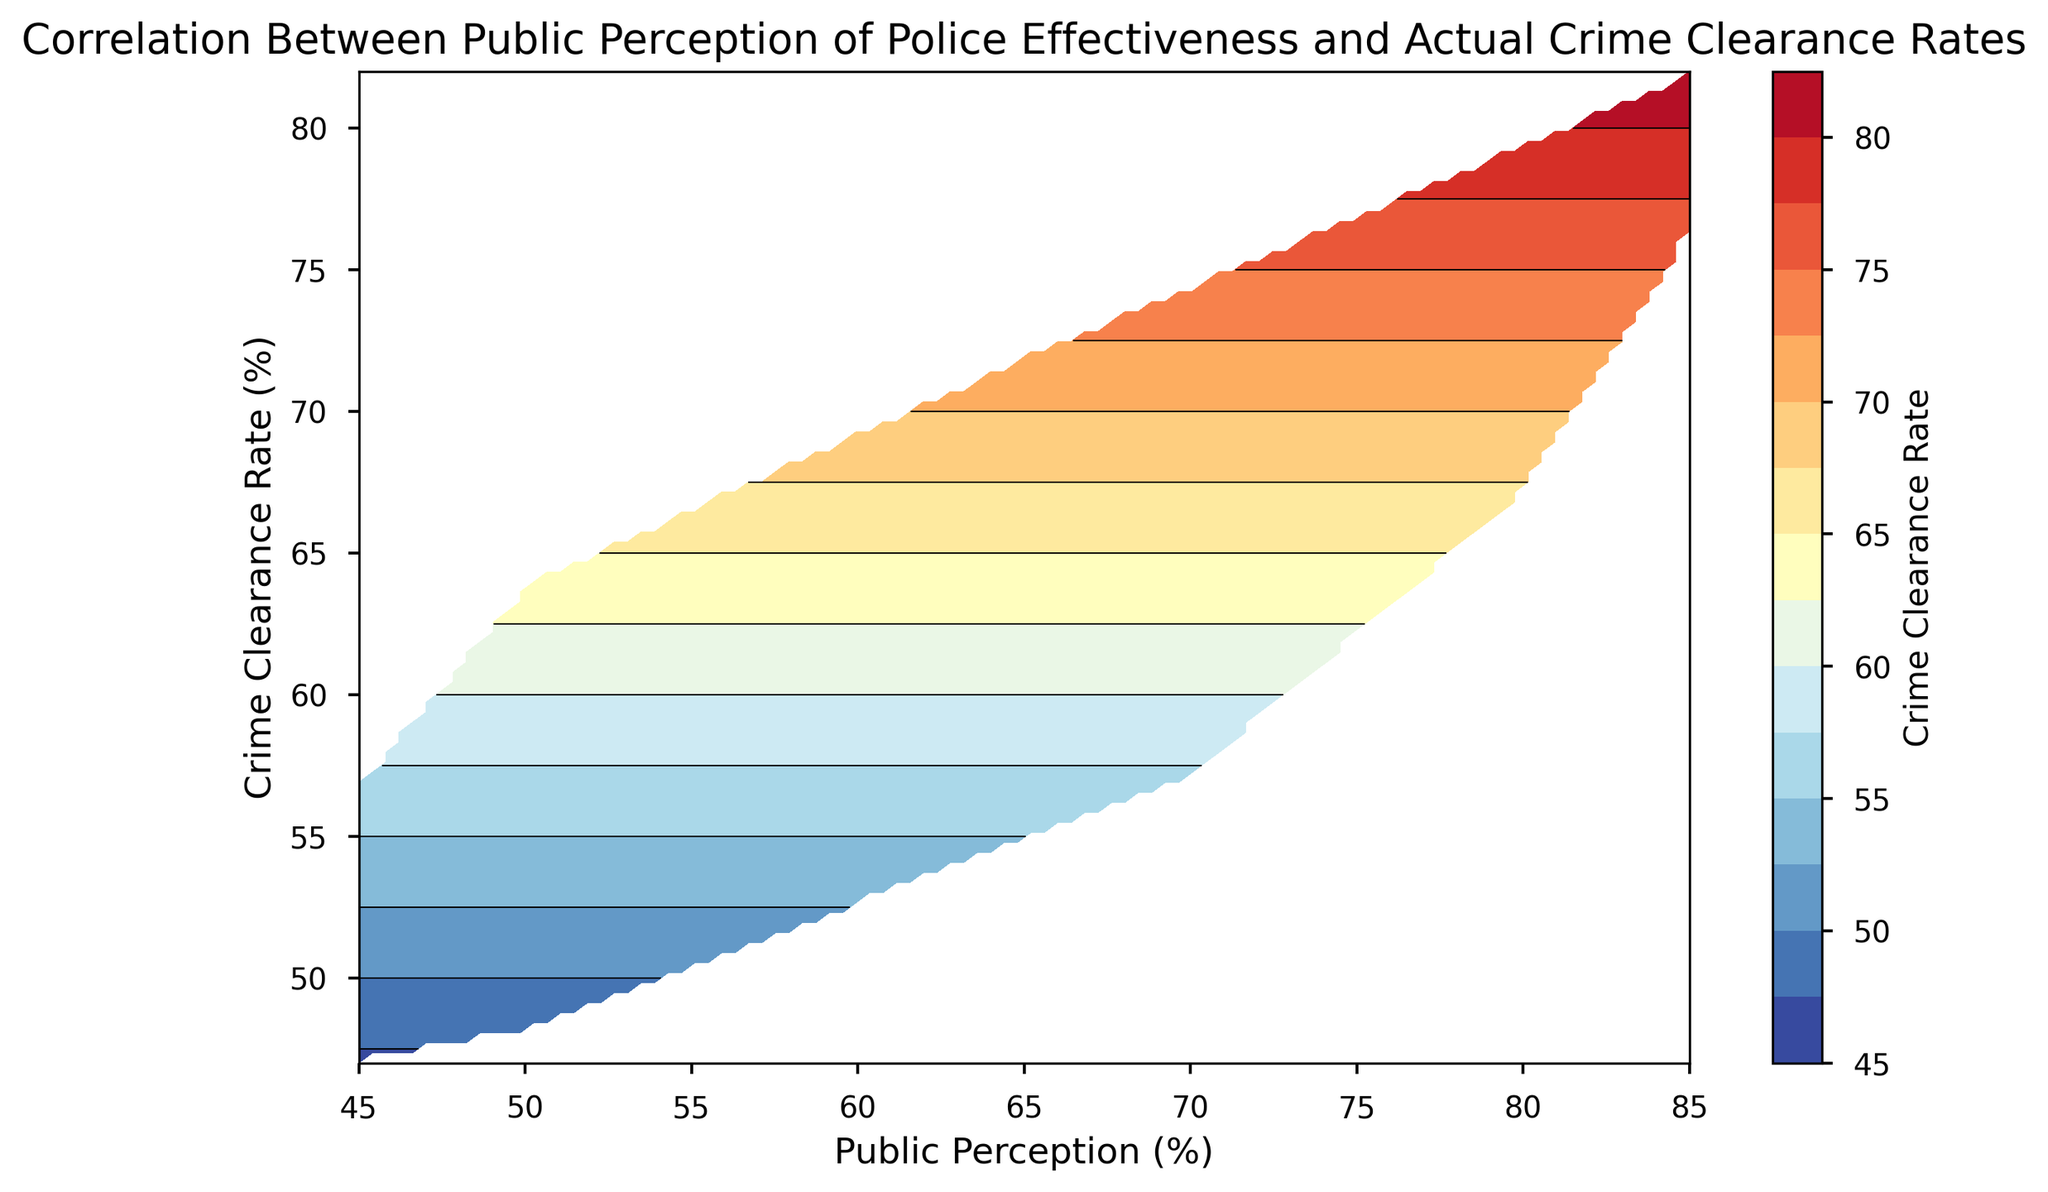What is the general trend between public perception and crime clearance rate? By observing the contour plot, it is evident that as public perception increases, the crime clearance rate also tends to increase, indicating a positive correlation.
Answer: Positive correlation Is there any specific range of public perception where crime clearance rates are highest? Based on the contour plot, the highest crime clearance rates appear to be in the upper ranges of public perception, around 80% and above.
Answer: Around 80% and above Which area has a more concentrated color, indicating higher crime clearance rates? The deeper colors in the contour plot, particularly in the upper right corner, indicate higher crime clearance rates, generally where public perception is also high.
Answer: The upper right corner Compare the crime clearance rates when public perception is around 50% and around 80%. Which is higher? Observing the contour lines and colors, the crime clearance rates around 80% public perception are noticeably higher than those around 50%.
Answer: Around 80% If the public perception is at 70%, what is the approximate crime clearance rate? By locating 70% on the x-axis and following it upwards to the contour lines, the corresponding crime clearance rate is approximately in the range of 68% to 74%.
Answer: 68% to 74% From the graph, when public perception is 60%, what is the range of crime clearance rates? For public perception at 60%, following the x-axis up to the y-axis, the crime clearance rate varies approximately between 58% and 68%.
Answer: 58% to 68% Which public perception percentage corresponds to the most diverse range of crime clearance rates? Public perception around 50% shows the widest range of crime clearance rates, from approximately 48% to 64%, according to the contour density.
Answer: Around 50% What color indicates the lowest levels of crime clearance rate? The lightest colors in the contour plot represent the lowest levels of crime clearance rates.
Answer: Lightest colors How does the spread of crime clearance rates change as public perception increases from 45% to 85%? The spread of crime clearance rates becomes narrower as public perception increases, indicating more consistent and higher crime clearance rates at higher public perception levels.
Answer: Narrower and higher spread 